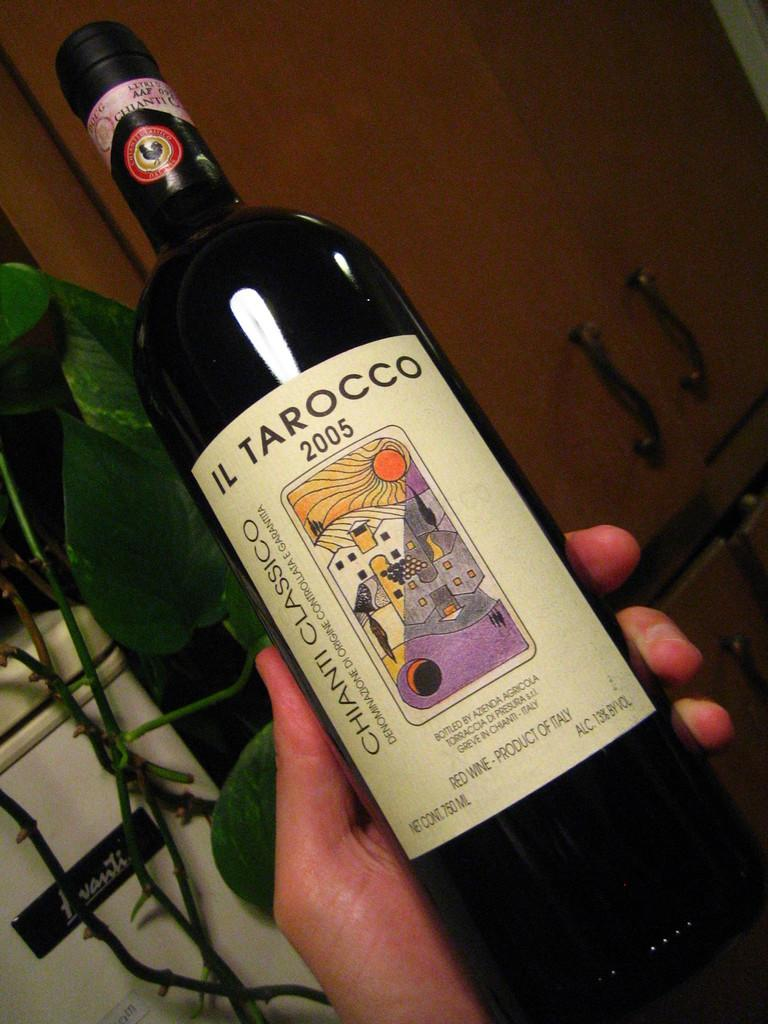<image>
Offer a succinct explanation of the picture presented. A classic black wine bottle from IL Tarocco 